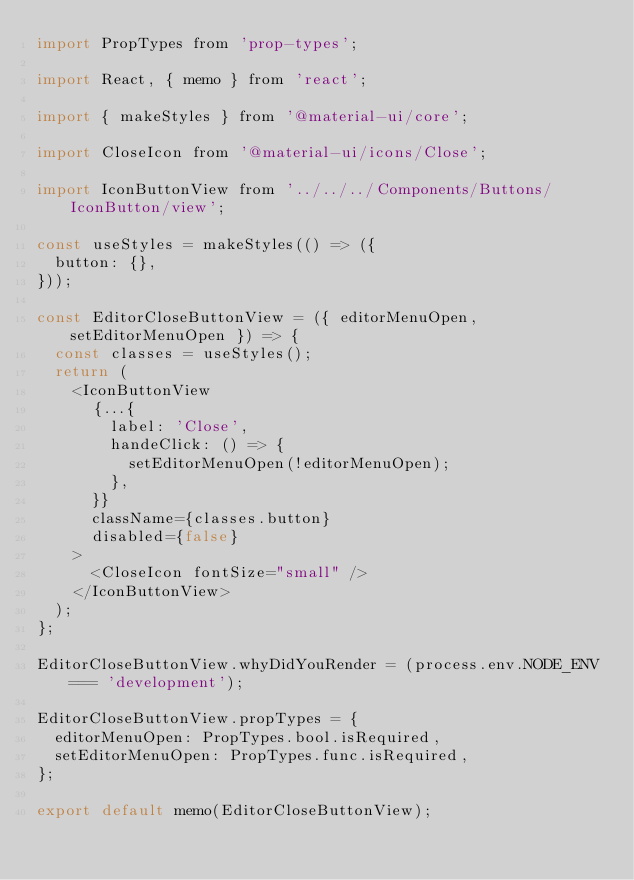<code> <loc_0><loc_0><loc_500><loc_500><_JavaScript_>import PropTypes from 'prop-types';

import React, { memo } from 'react';

import { makeStyles } from '@material-ui/core';

import CloseIcon from '@material-ui/icons/Close';

import IconButtonView from '../../../Components/Buttons/IconButton/view';

const useStyles = makeStyles(() => ({
  button: {},
}));

const EditorCloseButtonView = ({ editorMenuOpen, setEditorMenuOpen }) => {
  const classes = useStyles();
  return (
    <IconButtonView
      {...{
        label: 'Close',
        handeClick: () => {
          setEditorMenuOpen(!editorMenuOpen);
        },
      }}
      className={classes.button}
      disabled={false}
    >
      <CloseIcon fontSize="small" />
    </IconButtonView>
  );
};

EditorCloseButtonView.whyDidYouRender = (process.env.NODE_ENV === 'development');

EditorCloseButtonView.propTypes = {
  editorMenuOpen: PropTypes.bool.isRequired,
  setEditorMenuOpen: PropTypes.func.isRequired,
};

export default memo(EditorCloseButtonView);
</code> 